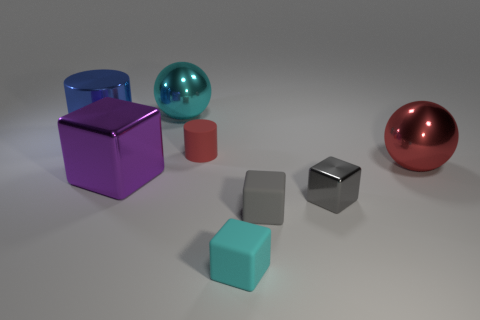There is a cyan metal thing; is its size the same as the rubber thing behind the purple metal object?
Offer a very short reply. No. Are there more red metal things than cylinders?
Provide a short and direct response. No. Are the red thing to the left of the tiny shiny cube and the cyan object that is in front of the tiny matte cylinder made of the same material?
Offer a very short reply. Yes. What material is the purple thing?
Your answer should be compact. Metal. Is the number of rubber things right of the cyan matte object greater than the number of big yellow metallic cubes?
Offer a very short reply. Yes. How many red spheres are to the left of the block on the left side of the cyan thing that is to the right of the cyan metal object?
Make the answer very short. 0. There is a object that is behind the purple metallic thing and on the right side of the tiny rubber cylinder; what is its material?
Offer a very short reply. Metal. What color is the small metal cube?
Provide a succinct answer. Gray. Are there more red shiny things that are behind the tiny red cylinder than small red matte cylinders that are behind the small cyan rubber cube?
Make the answer very short. No. What color is the large sphere in front of the cyan shiny ball?
Offer a terse response. Red. 